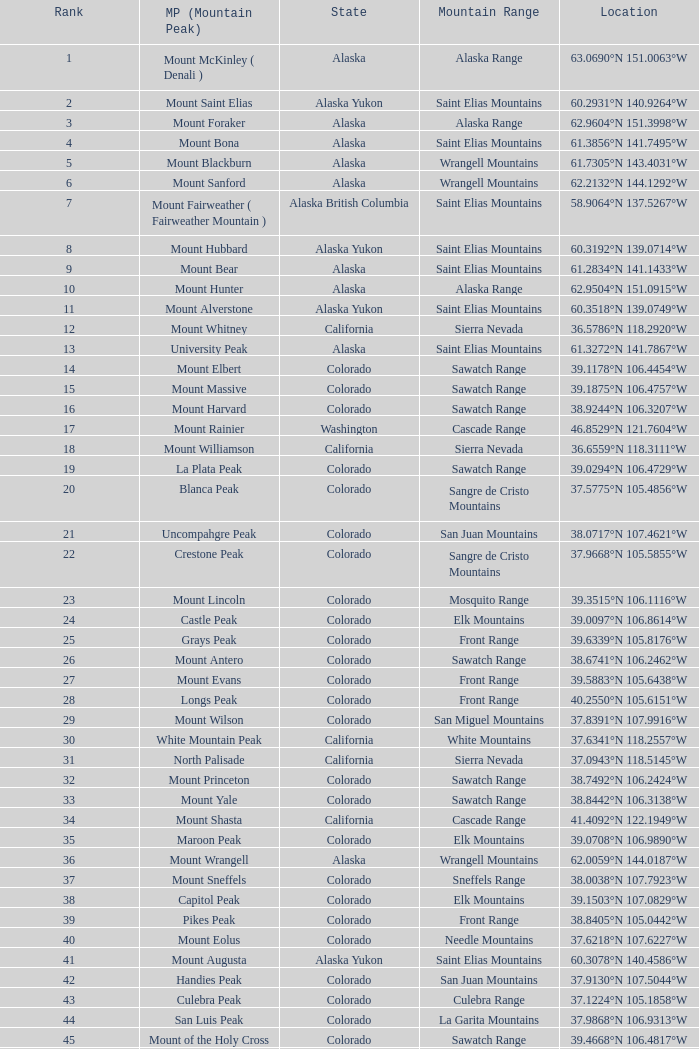What is the rank when the state is colorado and the location is 37.7859°n 107.7039°w? 83.0. 